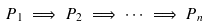Convert formula to latex. <formula><loc_0><loc_0><loc_500><loc_500>P _ { 1 } \implies P _ { 2 } \implies \dots \implies P _ { n }</formula> 